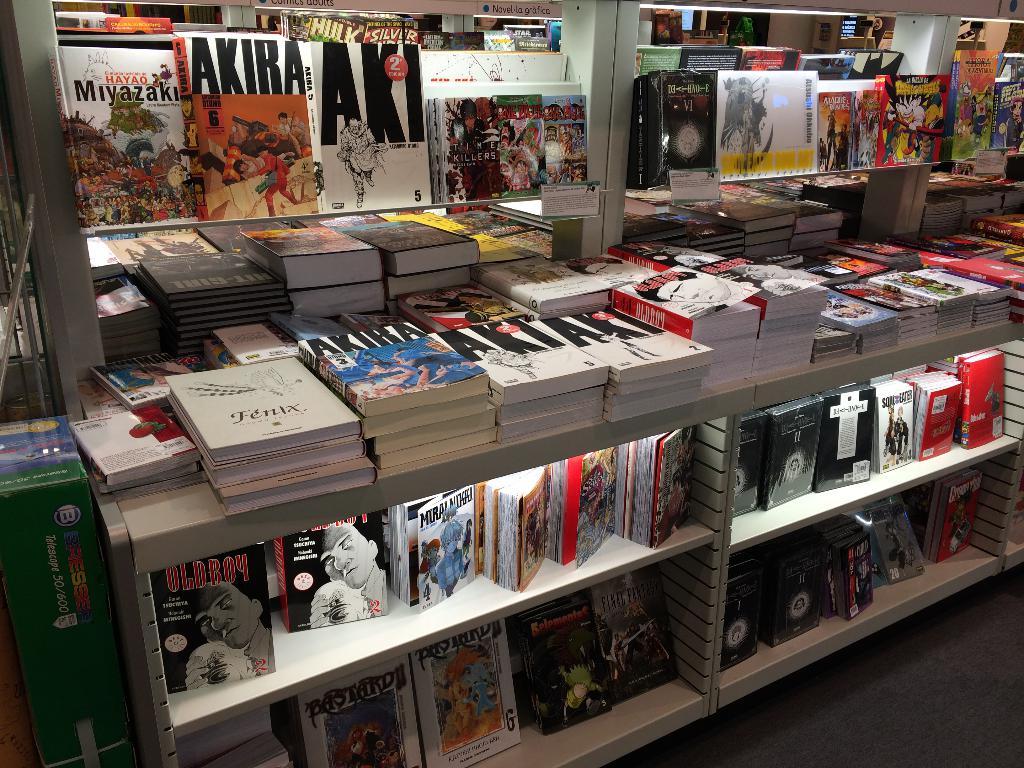What volume in the series is the orange & white akira graphic novel on the left of the top shelf?
Ensure brevity in your answer.  6. 